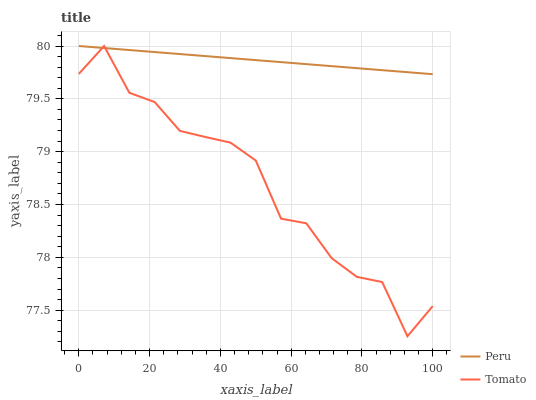Does Tomato have the minimum area under the curve?
Answer yes or no. Yes. Does Peru have the maximum area under the curve?
Answer yes or no. Yes. Does Peru have the minimum area under the curve?
Answer yes or no. No. Is Peru the smoothest?
Answer yes or no. Yes. Is Tomato the roughest?
Answer yes or no. Yes. Is Peru the roughest?
Answer yes or no. No. Does Peru have the lowest value?
Answer yes or no. No. 